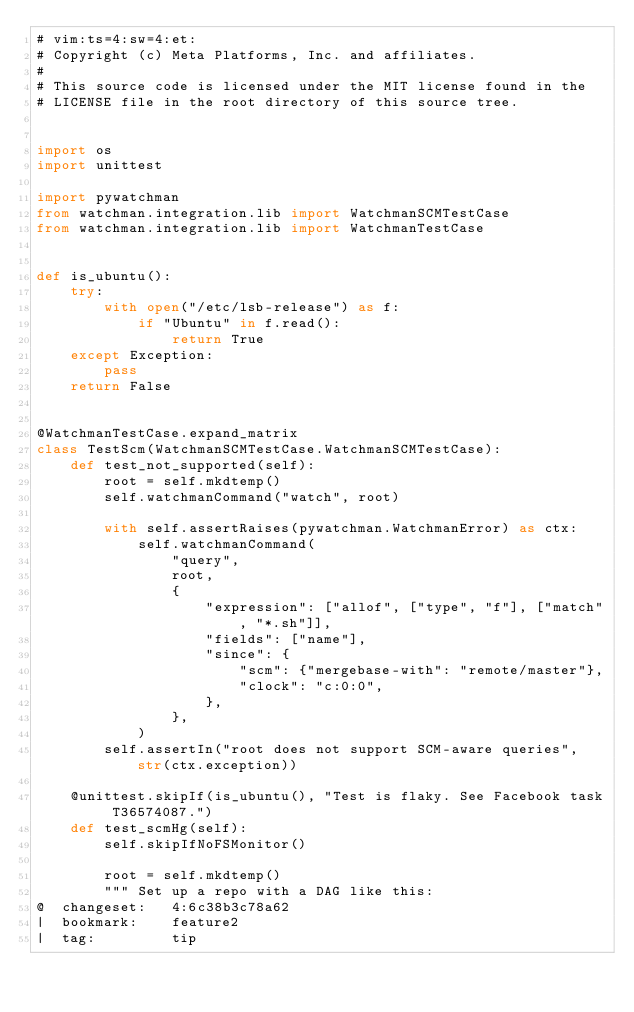Convert code to text. <code><loc_0><loc_0><loc_500><loc_500><_Python_># vim:ts=4:sw=4:et:
# Copyright (c) Meta Platforms, Inc. and affiliates.
#
# This source code is licensed under the MIT license found in the
# LICENSE file in the root directory of this source tree.


import os
import unittest

import pywatchman
from watchman.integration.lib import WatchmanSCMTestCase
from watchman.integration.lib import WatchmanTestCase


def is_ubuntu():
    try:
        with open("/etc/lsb-release") as f:
            if "Ubuntu" in f.read():
                return True
    except Exception:
        pass
    return False


@WatchmanTestCase.expand_matrix
class TestScm(WatchmanSCMTestCase.WatchmanSCMTestCase):
    def test_not_supported(self):
        root = self.mkdtemp()
        self.watchmanCommand("watch", root)

        with self.assertRaises(pywatchman.WatchmanError) as ctx:
            self.watchmanCommand(
                "query",
                root,
                {
                    "expression": ["allof", ["type", "f"], ["match", "*.sh"]],
                    "fields": ["name"],
                    "since": {
                        "scm": {"mergebase-with": "remote/master"},
                        "clock": "c:0:0",
                    },
                },
            )
        self.assertIn("root does not support SCM-aware queries", str(ctx.exception))

    @unittest.skipIf(is_ubuntu(), "Test is flaky. See Facebook task T36574087.")
    def test_scmHg(self):
        self.skipIfNoFSMonitor()

        root = self.mkdtemp()
        """ Set up a repo with a DAG like this:
@  changeset:   4:6c38b3c78a62
|  bookmark:    feature2
|  tag:         tip</code> 